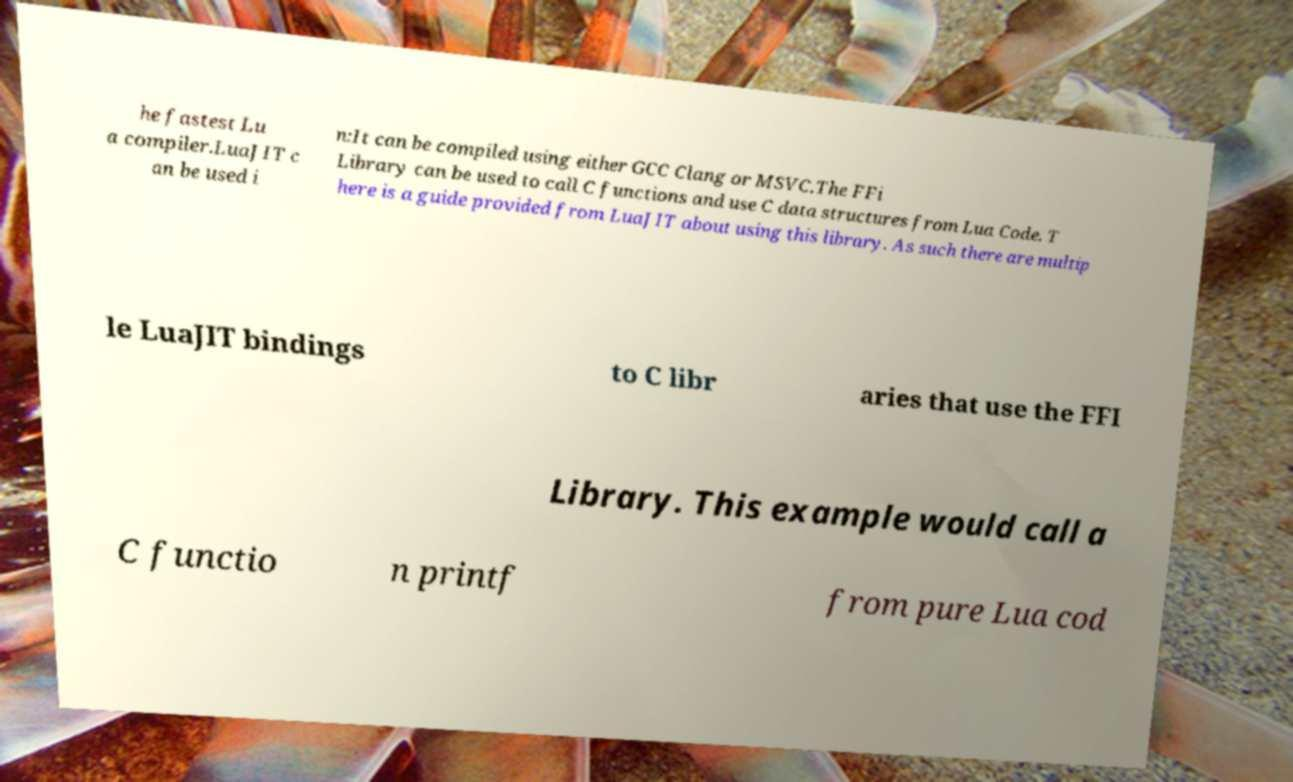For documentation purposes, I need the text within this image transcribed. Could you provide that? he fastest Lu a compiler.LuaJIT c an be used i n:It can be compiled using either GCC Clang or MSVC.The FFi Library can be used to call C functions and use C data structures from Lua Code. T here is a guide provided from LuaJIT about using this library. As such there are multip le LuaJIT bindings to C libr aries that use the FFI Library. This example would call a C functio n printf from pure Lua cod 